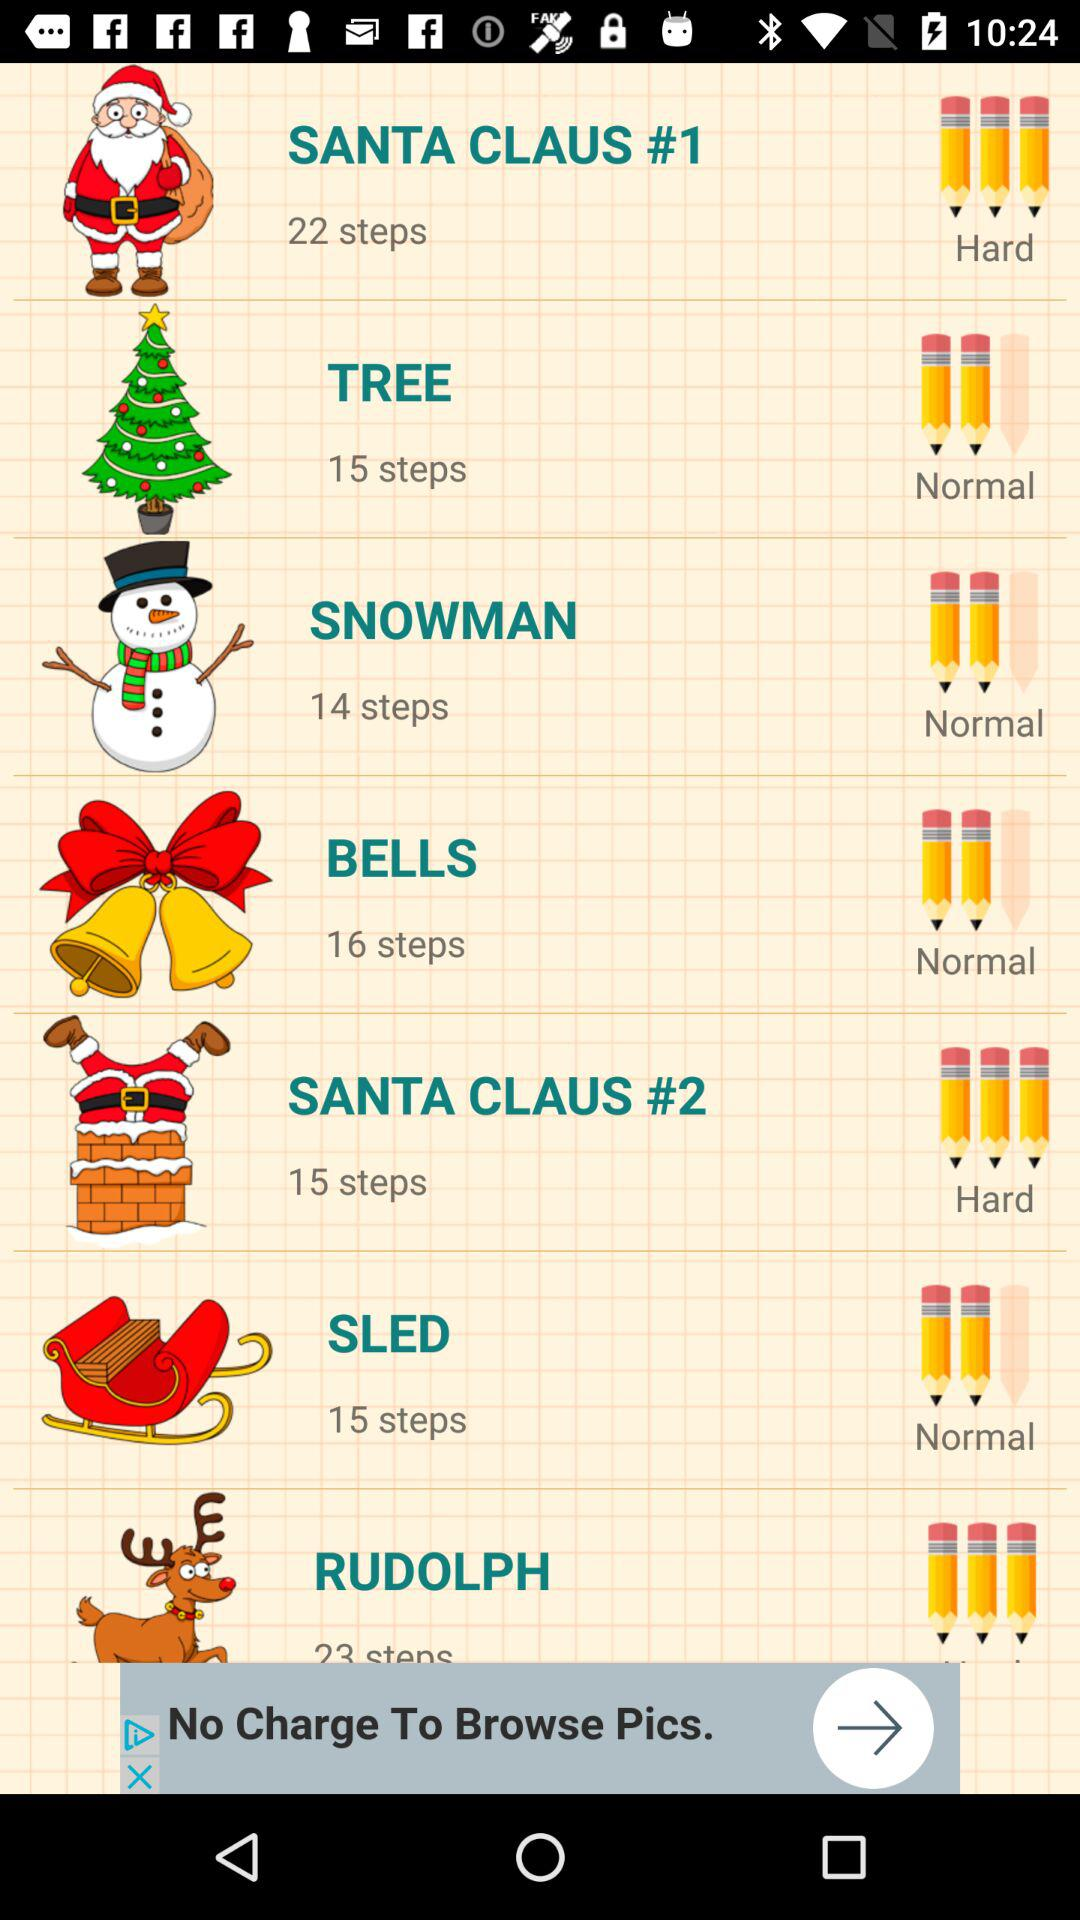How many steps are there for "SANTA CLAUS #1"? There are 22 steps. 